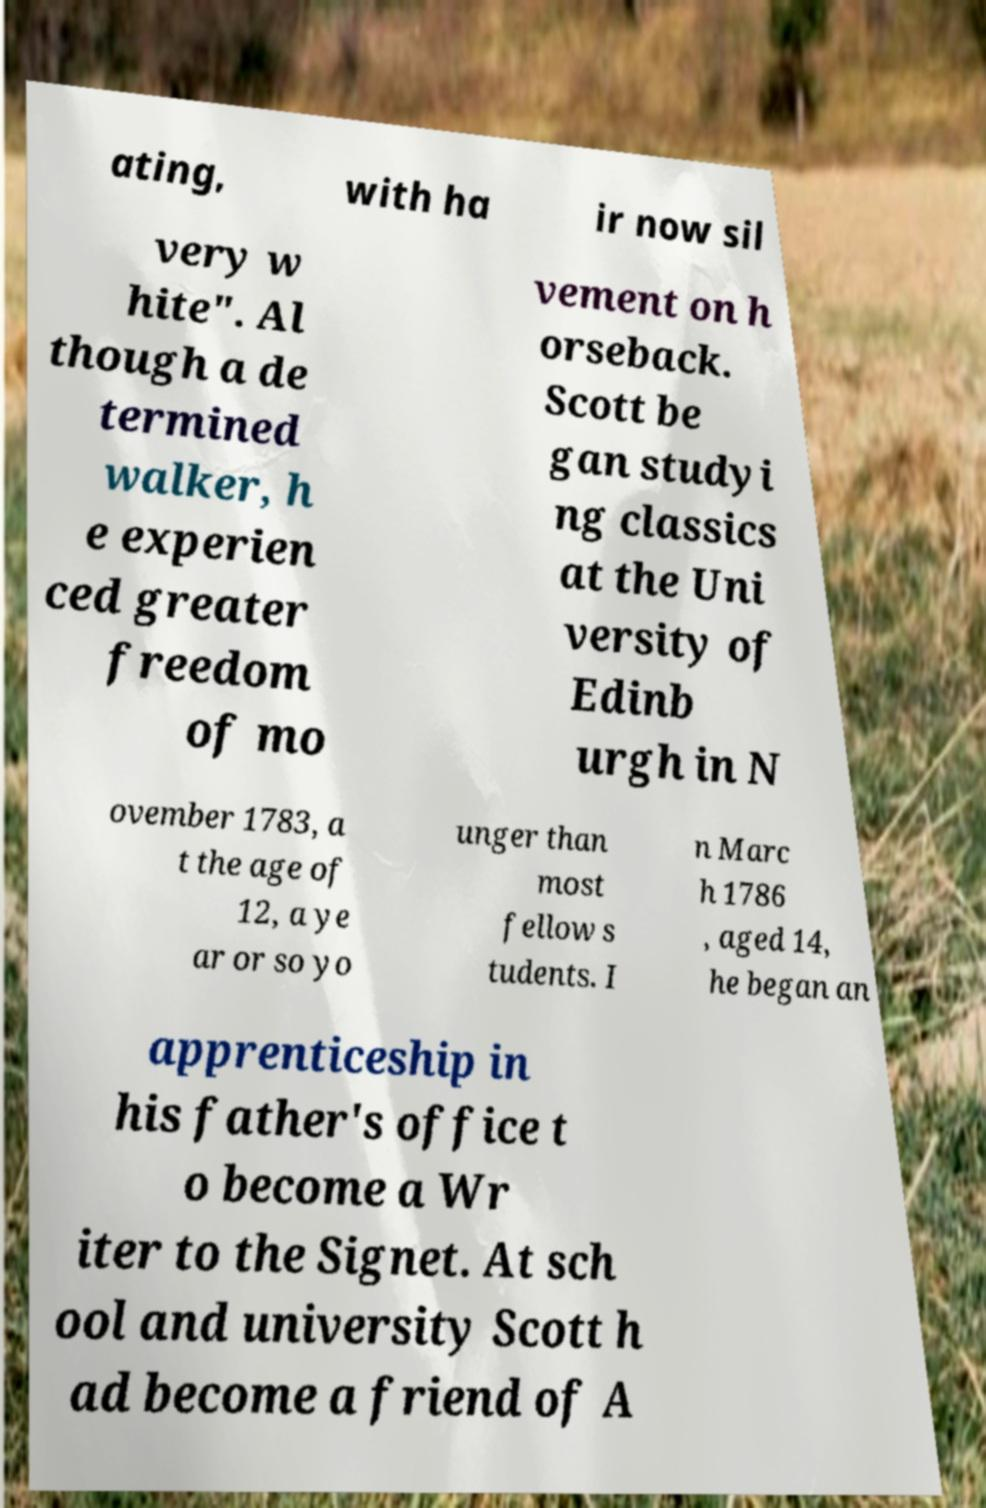Could you extract and type out the text from this image? ating, with ha ir now sil very w hite". Al though a de termined walker, h e experien ced greater freedom of mo vement on h orseback. Scott be gan studyi ng classics at the Uni versity of Edinb urgh in N ovember 1783, a t the age of 12, a ye ar or so yo unger than most fellow s tudents. I n Marc h 1786 , aged 14, he began an apprenticeship in his father's office t o become a Wr iter to the Signet. At sch ool and university Scott h ad become a friend of A 